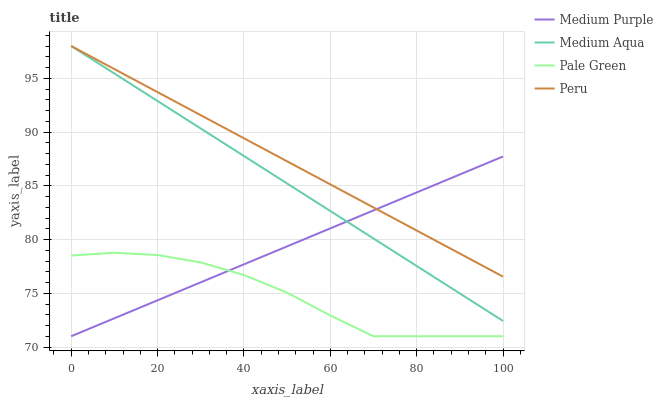Does Pale Green have the minimum area under the curve?
Answer yes or no. Yes. Does Peru have the maximum area under the curve?
Answer yes or no. Yes. Does Medium Aqua have the minimum area under the curve?
Answer yes or no. No. Does Medium Aqua have the maximum area under the curve?
Answer yes or no. No. Is Medium Aqua the smoothest?
Answer yes or no. Yes. Is Pale Green the roughest?
Answer yes or no. Yes. Is Pale Green the smoothest?
Answer yes or no. No. Is Medium Aqua the roughest?
Answer yes or no. No. Does Medium Purple have the lowest value?
Answer yes or no. Yes. Does Medium Aqua have the lowest value?
Answer yes or no. No. Does Peru have the highest value?
Answer yes or no. Yes. Does Pale Green have the highest value?
Answer yes or no. No. Is Pale Green less than Peru?
Answer yes or no. Yes. Is Medium Aqua greater than Pale Green?
Answer yes or no. Yes. Does Peru intersect Medium Aqua?
Answer yes or no. Yes. Is Peru less than Medium Aqua?
Answer yes or no. No. Is Peru greater than Medium Aqua?
Answer yes or no. No. Does Pale Green intersect Peru?
Answer yes or no. No. 